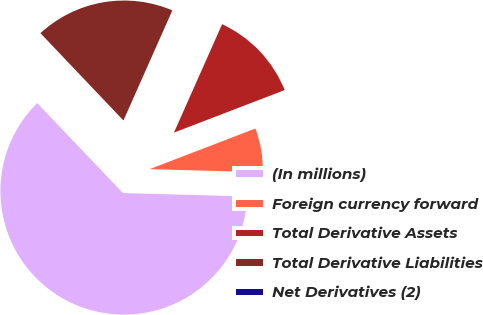<chart> <loc_0><loc_0><loc_500><loc_500><pie_chart><fcel>(In millions)<fcel>Foreign currency forward<fcel>Total Derivative Assets<fcel>Total Derivative Liabilities<fcel>Net Derivatives (2)<nl><fcel>62.43%<fcel>6.27%<fcel>12.51%<fcel>18.75%<fcel>0.03%<nl></chart> 